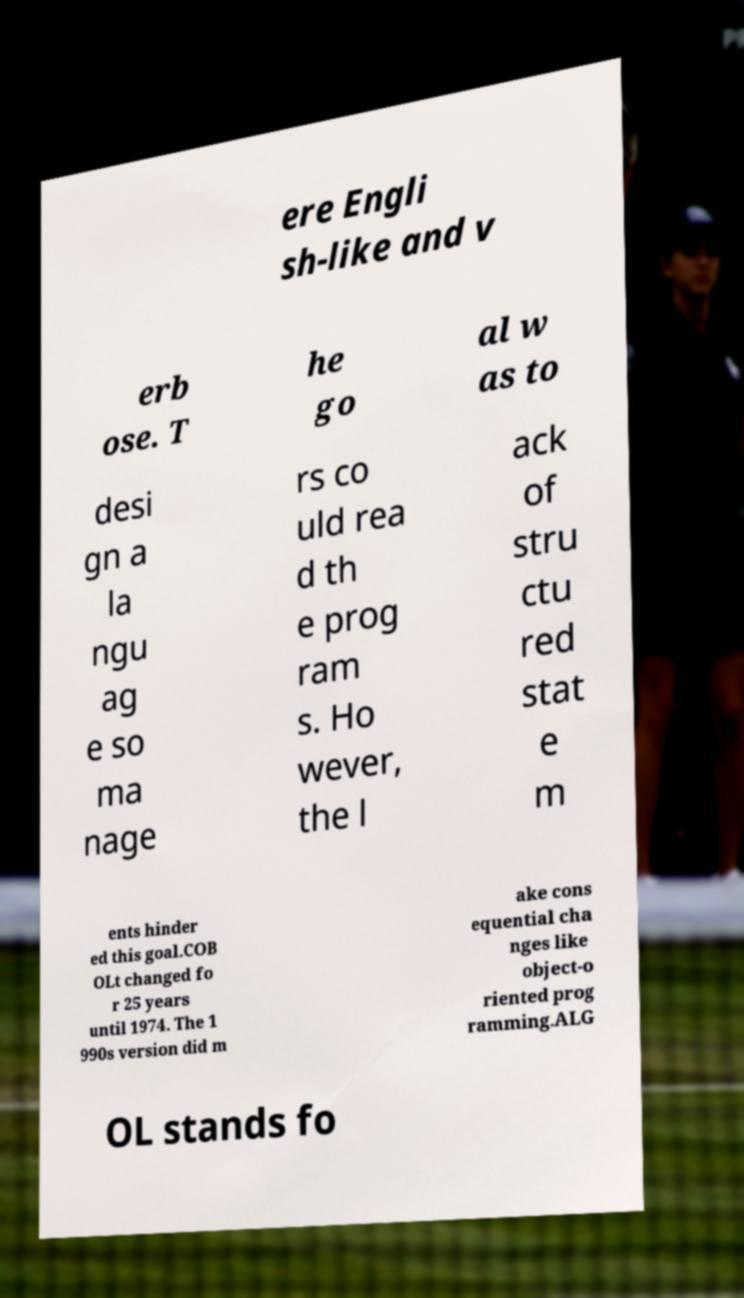Please identify and transcribe the text found in this image. ere Engli sh-like and v erb ose. T he go al w as to desi gn a la ngu ag e so ma nage rs co uld rea d th e prog ram s. Ho wever, the l ack of stru ctu red stat e m ents hinder ed this goal.COB OLt changed fo r 25 years until 1974. The 1 990s version did m ake cons equential cha nges like object-o riented prog ramming.ALG OL stands fo 